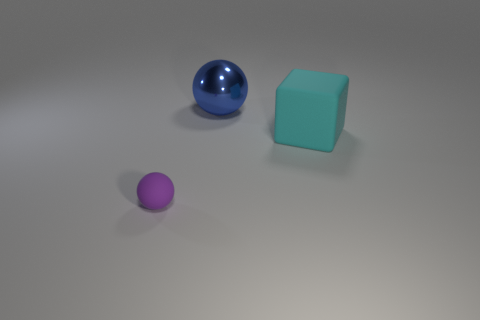Are there an equal number of big cyan blocks behind the large blue metallic object and large blue rubber cylinders? yes 